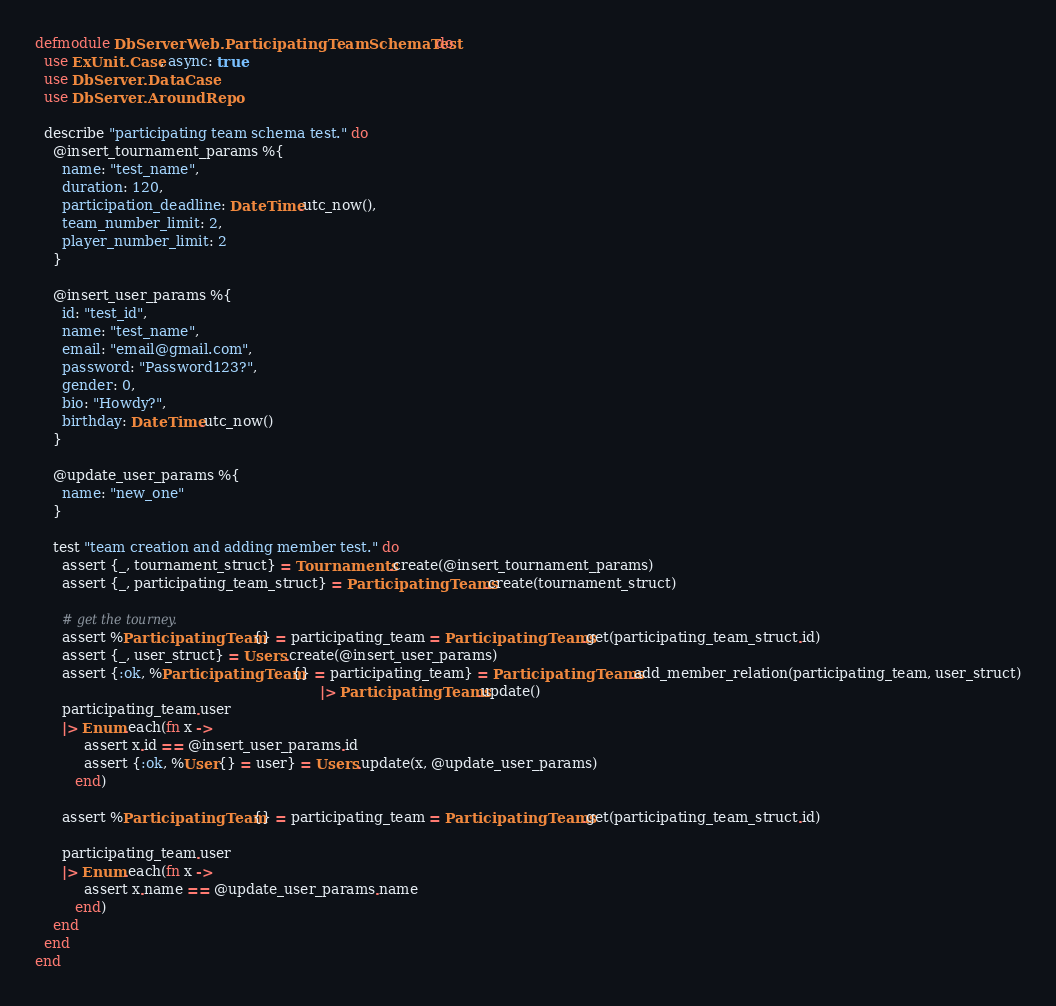<code> <loc_0><loc_0><loc_500><loc_500><_Elixir_>defmodule DbServerWeb.ParticipatingTeamSchemaTest do
  use ExUnit.Case, async: true
  use DbServer.DataCase
  use DbServer.AroundRepo

  describe "participating team schema test." do
    @insert_tournament_params %{
      name: "test_name",
      duration: 120,
      participation_deadline: DateTime.utc_now(),
      team_number_limit: 2,
      player_number_limit: 2
    }

    @insert_user_params %{
      id: "test_id",
      name: "test_name",
      email: "email@gmail.com",
      password: "Password123?",
      gender: 0,
      bio: "Howdy?",
      birthday: DateTime.utc_now()
    }

    @update_user_params %{
      name: "new_one"
    }

    test "team creation and adding member test." do
      assert {_, tournament_struct} = Tournaments.create(@insert_tournament_params)
      assert {_, participating_team_struct} = ParticipatingTeams.create(tournament_struct)

      # get the tourney.
      assert %ParticipatingTeam{} = participating_team = ParticipatingTeams.get(participating_team_struct.id)
      assert {_, user_struct} = Users.create(@insert_user_params)
      assert {:ok, %ParticipatingTeam{} = participating_team} = ParticipatingTeams.add_member_relation(participating_team, user_struct)
                                                                |> ParticipatingTeams.update()
      participating_team.user
      |> Enum.each(fn x ->
           assert x.id == @insert_user_params.id
           assert {:ok, %User{} = user} = Users.update(x, @update_user_params)
         end)
      
      assert %ParticipatingTeam{} = participating_team = ParticipatingTeams.get(participating_team_struct.id)

      participating_team.user
      |> Enum.each(fn x ->
           assert x.name == @update_user_params.name
         end)
    end
  end
end</code> 